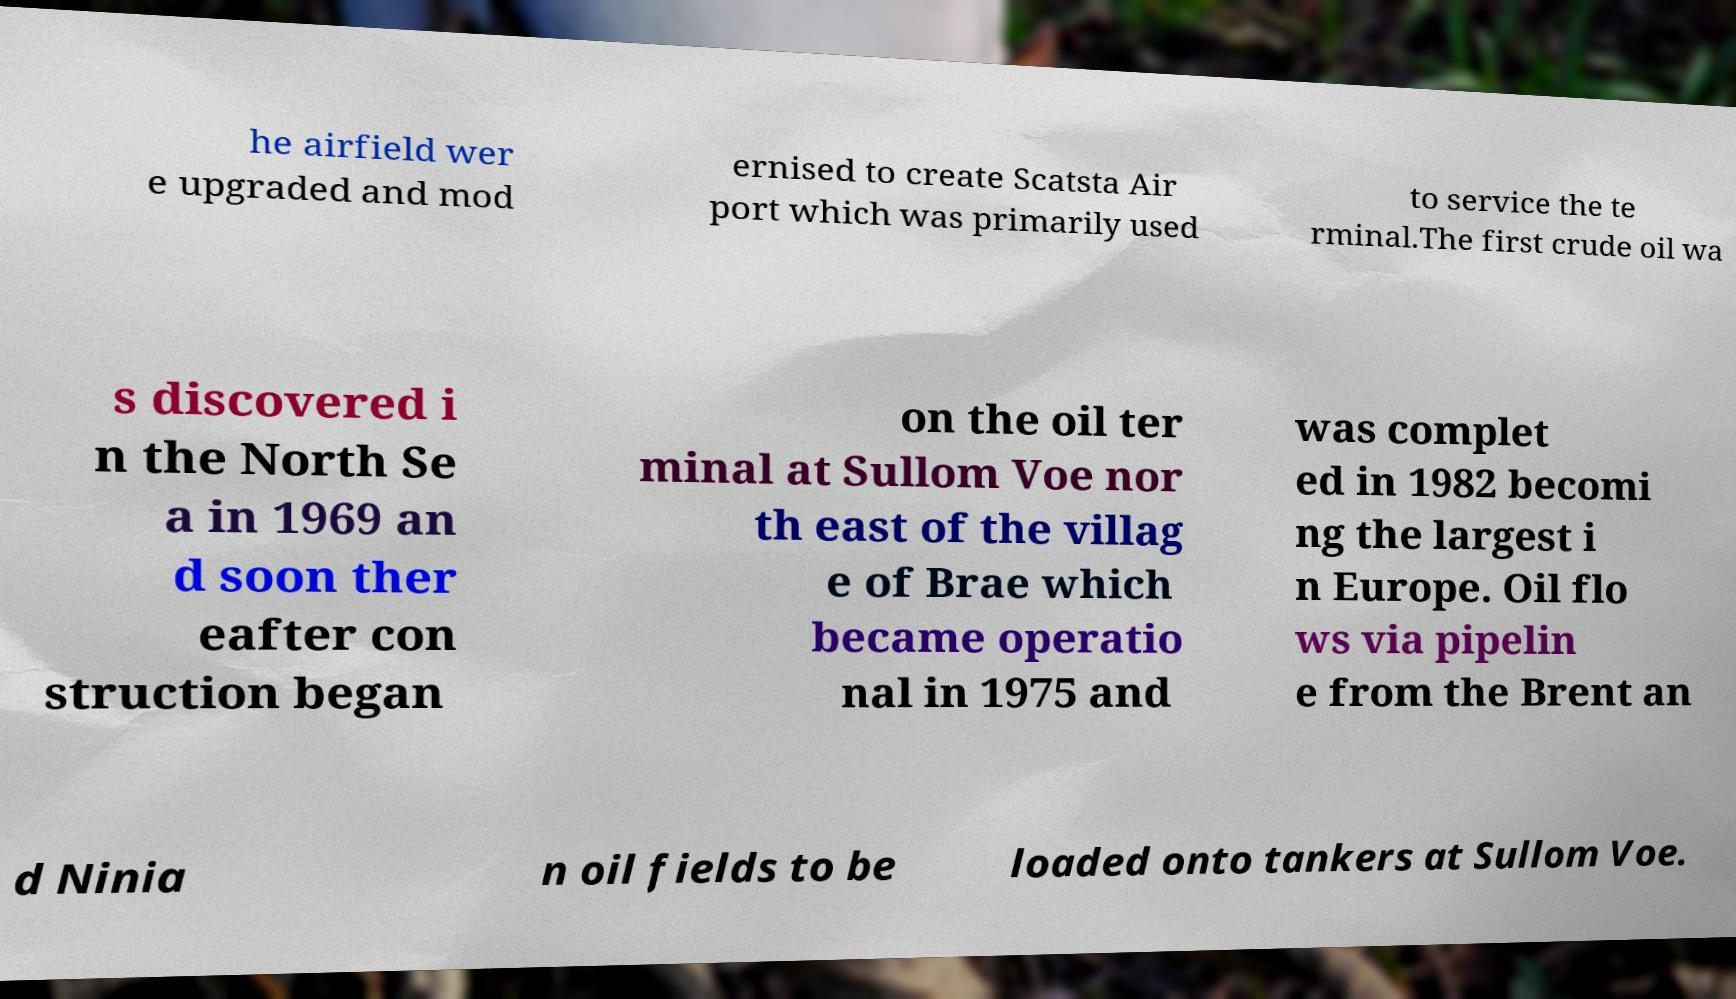Can you read and provide the text displayed in the image?This photo seems to have some interesting text. Can you extract and type it out for me? he airfield wer e upgraded and mod ernised to create Scatsta Air port which was primarily used to service the te rminal.The first crude oil wa s discovered i n the North Se a in 1969 an d soon ther eafter con struction began on the oil ter minal at Sullom Voe nor th east of the villag e of Brae which became operatio nal in 1975 and was complet ed in 1982 becomi ng the largest i n Europe. Oil flo ws via pipelin e from the Brent an d Ninia n oil fields to be loaded onto tankers at Sullom Voe. 